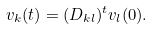<formula> <loc_0><loc_0><loc_500><loc_500>v _ { k } ( t ) = ( D _ { k l } ) ^ { t } v _ { l } ( 0 ) .</formula> 